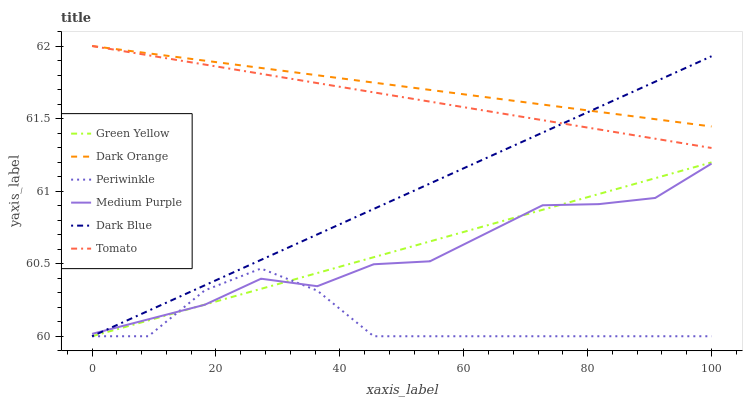Does Periwinkle have the minimum area under the curve?
Answer yes or no. Yes. Does Dark Orange have the maximum area under the curve?
Answer yes or no. Yes. Does Medium Purple have the minimum area under the curve?
Answer yes or no. No. Does Medium Purple have the maximum area under the curve?
Answer yes or no. No. Is Green Yellow the smoothest?
Answer yes or no. Yes. Is Periwinkle the roughest?
Answer yes or no. Yes. Is Dark Orange the smoothest?
Answer yes or no. No. Is Dark Orange the roughest?
Answer yes or no. No. Does Dark Blue have the lowest value?
Answer yes or no. Yes. Does Medium Purple have the lowest value?
Answer yes or no. No. Does Dark Orange have the highest value?
Answer yes or no. Yes. Does Medium Purple have the highest value?
Answer yes or no. No. Is Periwinkle less than Dark Orange?
Answer yes or no. Yes. Is Dark Orange greater than Medium Purple?
Answer yes or no. Yes. Does Tomato intersect Dark Orange?
Answer yes or no. Yes. Is Tomato less than Dark Orange?
Answer yes or no. No. Is Tomato greater than Dark Orange?
Answer yes or no. No. Does Periwinkle intersect Dark Orange?
Answer yes or no. No. 